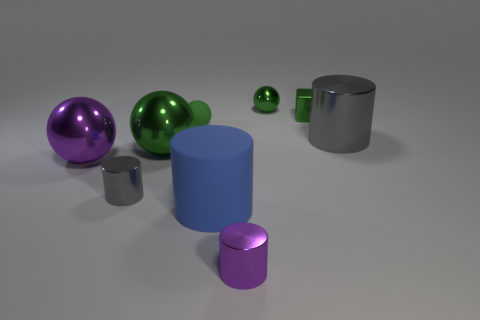How many large things are the same color as the tiny metallic sphere?
Your answer should be compact. 1. What number of things are either small green shiny balls or cubes?
Offer a terse response. 2. What material is the purple object on the right side of the blue matte cylinder behind the small purple metallic cylinder?
Give a very brief answer. Metal. Is there a large green object made of the same material as the small gray cylinder?
Make the answer very short. Yes. What shape is the small metal object in front of the gray object on the left side of the large cylinder behind the blue cylinder?
Provide a succinct answer. Cylinder. What is the material of the small purple thing?
Provide a short and direct response. Metal. What is the color of the small sphere that is made of the same material as the small purple thing?
Make the answer very short. Green. Are there any things that are to the right of the small cylinder that is on the left side of the big green thing?
Offer a terse response. Yes. How many other things are there of the same shape as the big purple metal thing?
Ensure brevity in your answer.  3. Do the purple thing in front of the small gray metal object and the large purple object that is on the left side of the blue object have the same shape?
Ensure brevity in your answer.  No. 